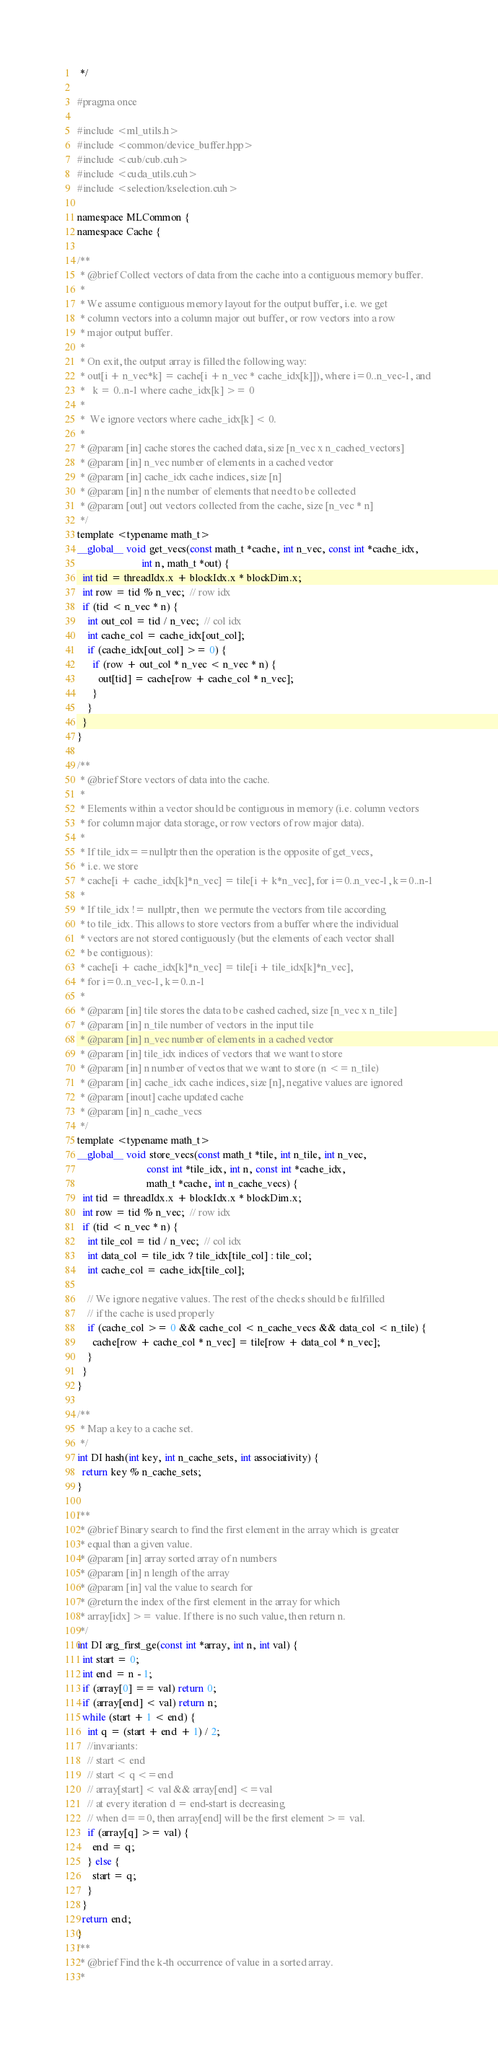<code> <loc_0><loc_0><loc_500><loc_500><_Cuda_> */

#pragma once

#include <ml_utils.h>
#include <common/device_buffer.hpp>
#include <cub/cub.cuh>
#include <cuda_utils.cuh>
#include <selection/kselection.cuh>

namespace MLCommon {
namespace Cache {

/**
 * @brief Collect vectors of data from the cache into a contiguous memory buffer.
 *
 * We assume contiguous memory layout for the output buffer, i.e. we get
 * column vectors into a column major out buffer, or row vectors into a row
 * major output buffer.
 *
 * On exit, the output array is filled the following way:
 * out[i + n_vec*k] = cache[i + n_vec * cache_idx[k]]), where i=0..n_vec-1, and
 *   k = 0..n-1 where cache_idx[k] >= 0
 *
 *  We ignore vectors where cache_idx[k] < 0.
 *
 * @param [in] cache stores the cached data, size [n_vec x n_cached_vectors]
 * @param [in] n_vec number of elements in a cached vector
 * @param [in] cache_idx cache indices, size [n]
 * @param [in] n the number of elements that need to be collected
 * @param [out] out vectors collected from the cache, size [n_vec * n]
 */
template <typename math_t>
__global__ void get_vecs(const math_t *cache, int n_vec, const int *cache_idx,
                         int n, math_t *out) {
  int tid = threadIdx.x + blockIdx.x * blockDim.x;
  int row = tid % n_vec;  // row idx
  if (tid < n_vec * n) {
    int out_col = tid / n_vec;  // col idx
    int cache_col = cache_idx[out_col];
    if (cache_idx[out_col] >= 0) {
      if (row + out_col * n_vec < n_vec * n) {
        out[tid] = cache[row + cache_col * n_vec];
      }
    }
  }
}

/**
 * @brief Store vectors of data into the cache.
 *
 * Elements within a vector should be contiguous in memory (i.e. column vectors
 * for column major data storage, or row vectors of row major data).
 *
 * If tile_idx==nullptr then the operation is the opposite of get_vecs,
 * i.e. we store
 * cache[i + cache_idx[k]*n_vec] = tile[i + k*n_vec], for i=0..n_vec-1, k=0..n-1
 *
 * If tile_idx != nullptr, then  we permute the vectors from tile according
 * to tile_idx. This allows to store vectors from a buffer where the individual
 * vectors are not stored contiguously (but the elements of each vector shall
 * be contiguous):
 * cache[i + cache_idx[k]*n_vec] = tile[i + tile_idx[k]*n_vec],
 * for i=0..n_vec-1, k=0..n-1
 *
 * @param [in] tile stores the data to be cashed cached, size [n_vec x n_tile]
 * @param [in] n_tile number of vectors in the input tile
 * @param [in] n_vec number of elements in a cached vector
 * @param [in] tile_idx indices of vectors that we want to store
 * @param [in] n number of vectos that we want to store (n <= n_tile)
 * @param [in] cache_idx cache indices, size [n], negative values are ignored
 * @param [inout] cache updated cache
 * @param [in] n_cache_vecs
 */
template <typename math_t>
__global__ void store_vecs(const math_t *tile, int n_tile, int n_vec,
                           const int *tile_idx, int n, const int *cache_idx,
                           math_t *cache, int n_cache_vecs) {
  int tid = threadIdx.x + blockIdx.x * blockDim.x;
  int row = tid % n_vec;  // row idx
  if (tid < n_vec * n) {
    int tile_col = tid / n_vec;  // col idx
    int data_col = tile_idx ? tile_idx[tile_col] : tile_col;
    int cache_col = cache_idx[tile_col];

    // We ignore negative values. The rest of the checks should be fulfilled
    // if the cache is used properly
    if (cache_col >= 0 && cache_col < n_cache_vecs && data_col < n_tile) {
      cache[row + cache_col * n_vec] = tile[row + data_col * n_vec];
    }
  }
}

/**
 * Map a key to a cache set.
 */
int DI hash(int key, int n_cache_sets, int associativity) {
  return key % n_cache_sets;
}

/**
 * @brief Binary search to find the first element in the array which is greater
 * equal than a given value.
 * @param [in] array sorted array of n numbers
 * @param [in] n length of the array
 * @param [in] val the value to search for
 * @return the index of the first element in the array for which
 * array[idx] >= value. If there is no such value, then return n.
 */
int DI arg_first_ge(const int *array, int n, int val) {
  int start = 0;
  int end = n - 1;
  if (array[0] == val) return 0;
  if (array[end] < val) return n;
  while (start + 1 < end) {
    int q = (start + end + 1) / 2;
    //invariants:
    // start < end
    // start < q <=end
    // array[start] < val && array[end] <=val
    // at every iteration d = end-start is decreasing
    // when d==0, then array[end] will be the first element >= val.
    if (array[q] >= val) {
      end = q;
    } else {
      start = q;
    }
  }
  return end;
}
/**
 * @brief Find the k-th occurrence of value in a sorted array.
 *</code> 